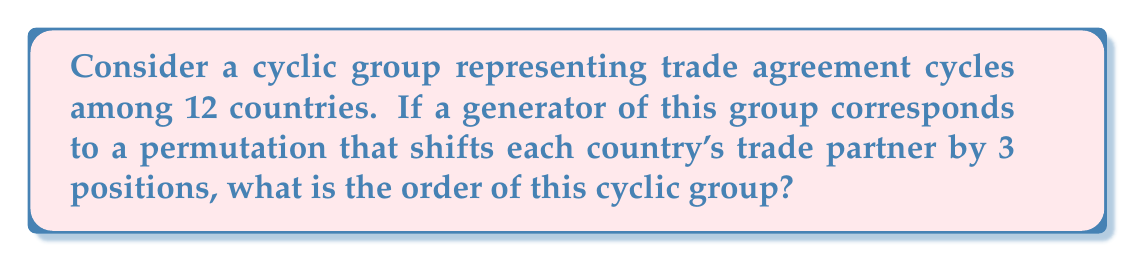Can you solve this math problem? To solve this problem, we need to follow these steps:

1) First, let's understand what the generator does. It shifts each country's trade partner by 3 positions. This can be represented as a permutation $(1 \, 4 \, 7 \, 10)(2 \, 5 \, 8 \, 11)(3 \, 6 \, 9 \, 12)$ in cycle notation.

2) The order of a cyclic group is the smallest positive integer $n$ such that $g^n = e$, where $g$ is the generator and $e$ is the identity element.

3) In permutation groups, this is equivalent to finding the least common multiple (LCM) of the lengths of the disjoint cycles in the permutation.

4) In our case, we have three cycles, each of length 4.

5) Therefore, the order of the group is:

   $\text{LCM}(4, 4, 4) = 4$

6) This means that after applying the generator 4 times, we return to the original trade agreement configuration.

7) We can verify this:
   - After 1 application: $(1 \, 4 \, 7 \, 10)(2 \, 5 \, 8 \, 11)(3 \, 6 \, 9 \, 12)$
   - After 2 applications: $(1 \, 7)(4 \, 10)(2 \, 8)(5 \, 11)(3 \, 9)(6 \, 12)$
   - After 3 applications: $(1 \, 10 \, 7 \, 4)(2 \, 11 \, 8 \, 5)(3 \, 12 \, 9 \, 6)$
   - After 4 applications: $(1)(2)(3)(4)(5)(6)(7)(8)(9)(10)(11)(12)$ (identity permutation)

Thus, the order of the cyclic group is 4.
Answer: The order of the cyclic group is 4. 